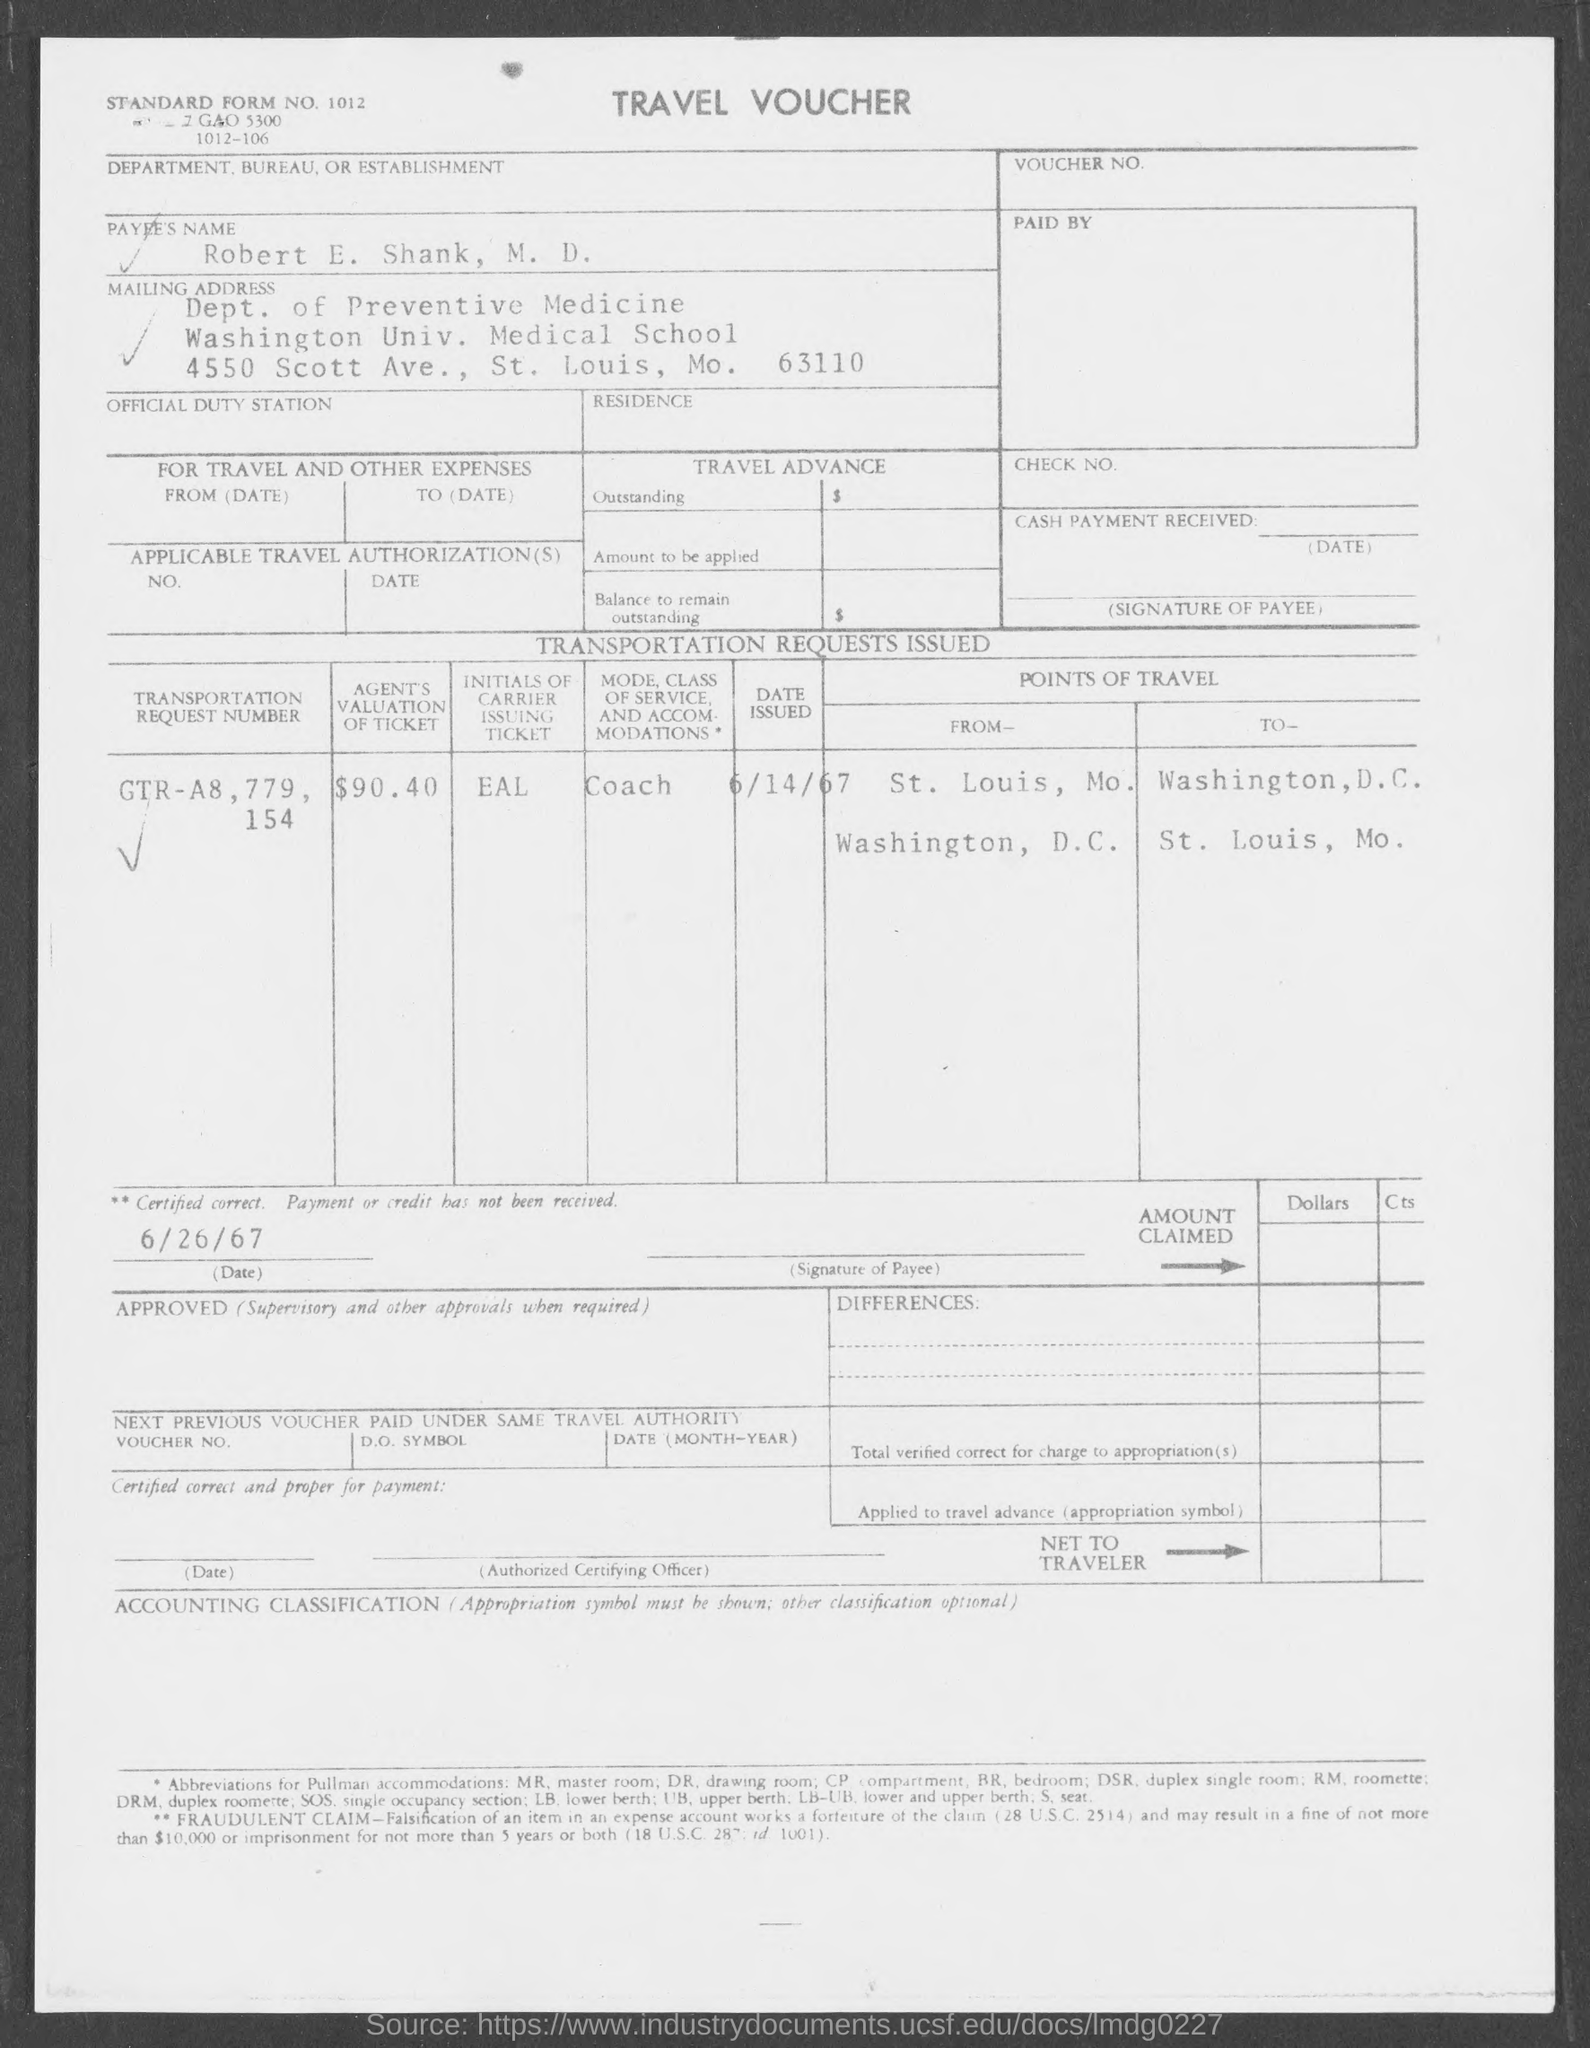Outline some significant characteristics in this image. The initials of the carrier issuing the ticket are EAL. The agent has estimated the value of the ticket to be $90.40. The payee's name listed on the voucher is ROBERT E. SHANK, M.D., as declared in the voucher. The issued date of the transportation request is June 14th, 1967. The transportation request number mentioned in the travel voucher is GTR-A8,779,154. 